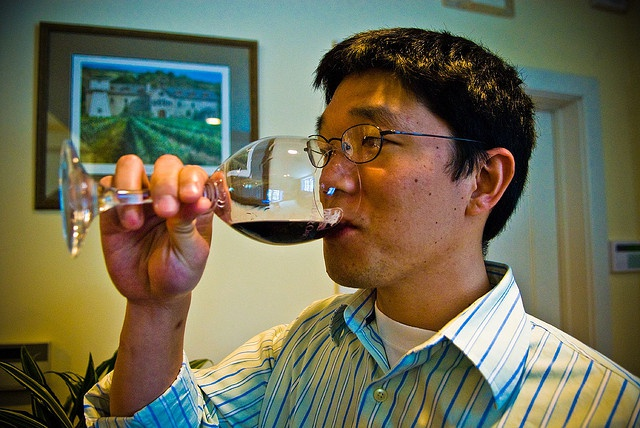Describe the objects in this image and their specific colors. I can see people in black, maroon, and brown tones, wine glass in black, darkgray, and gray tones, and potted plant in black and olive tones in this image. 